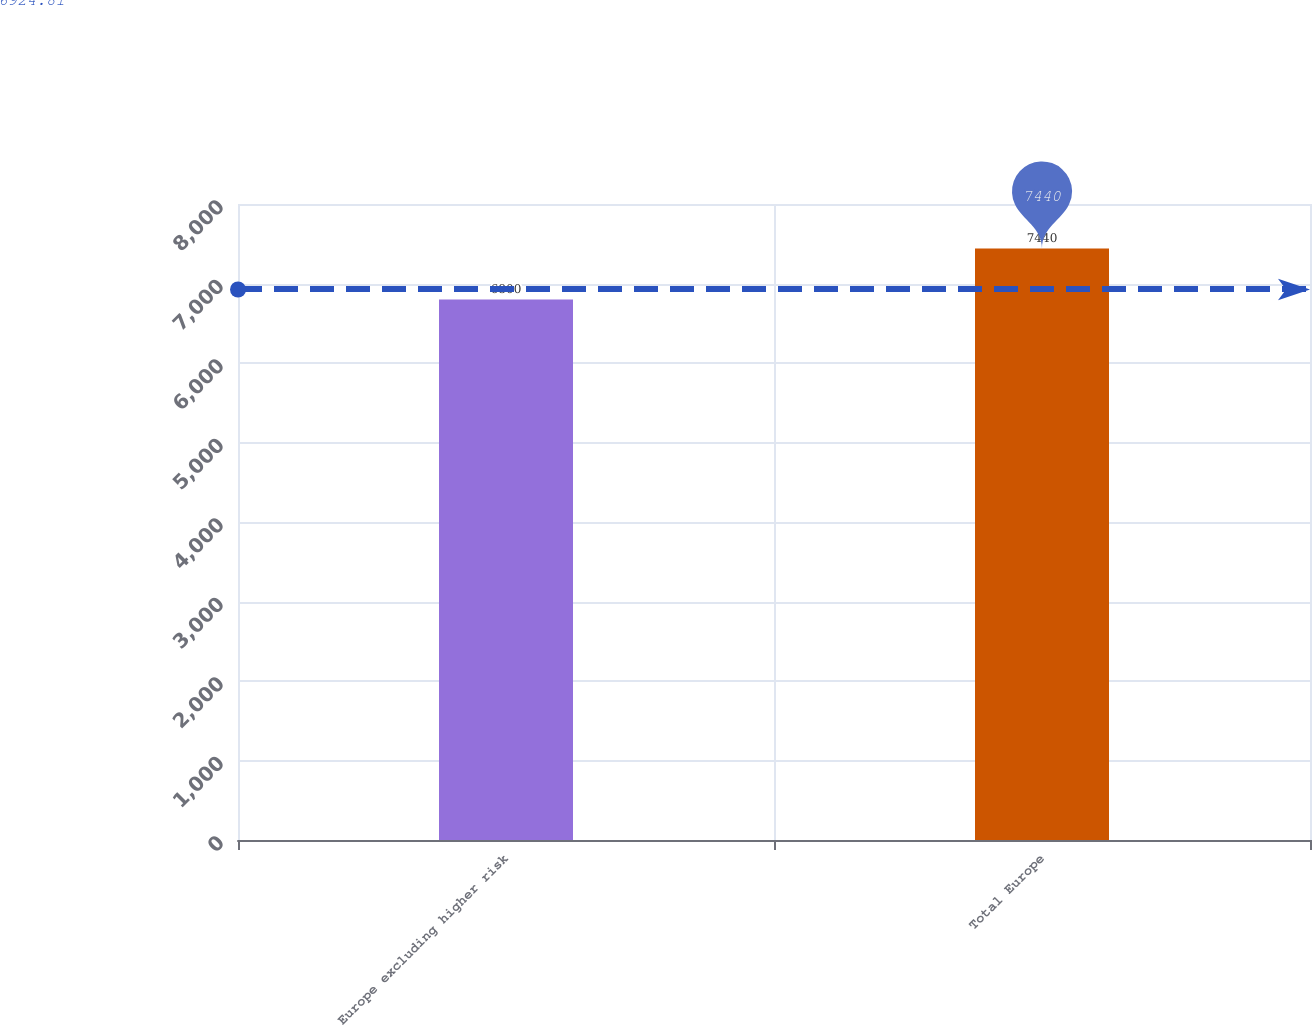Convert chart to OTSL. <chart><loc_0><loc_0><loc_500><loc_500><bar_chart><fcel>Europe excluding higher risk<fcel>Total Europe<nl><fcel>6800<fcel>7440<nl></chart> 